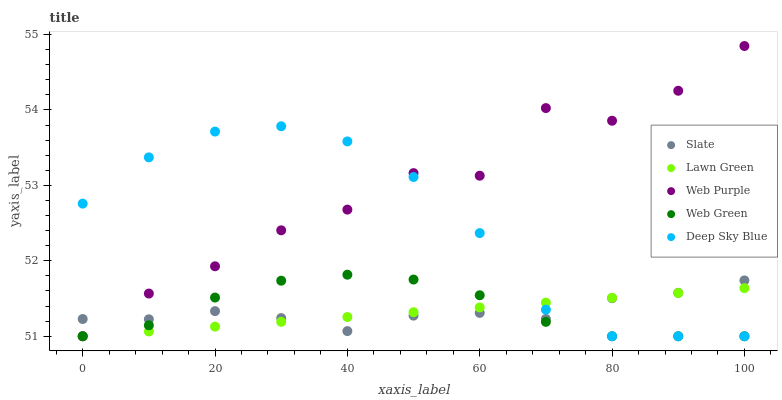Does Lawn Green have the minimum area under the curve?
Answer yes or no. Yes. Does Web Purple have the maximum area under the curve?
Answer yes or no. Yes. Does Slate have the minimum area under the curve?
Answer yes or no. No. Does Slate have the maximum area under the curve?
Answer yes or no. No. Is Lawn Green the smoothest?
Answer yes or no. Yes. Is Web Purple the roughest?
Answer yes or no. Yes. Is Slate the smoothest?
Answer yes or no. No. Is Slate the roughest?
Answer yes or no. No. Does Lawn Green have the lowest value?
Answer yes or no. Yes. Does Slate have the lowest value?
Answer yes or no. No. Does Web Purple have the highest value?
Answer yes or no. Yes. Does Slate have the highest value?
Answer yes or no. No. Does Web Purple intersect Lawn Green?
Answer yes or no. Yes. Is Web Purple less than Lawn Green?
Answer yes or no. No. Is Web Purple greater than Lawn Green?
Answer yes or no. No. 